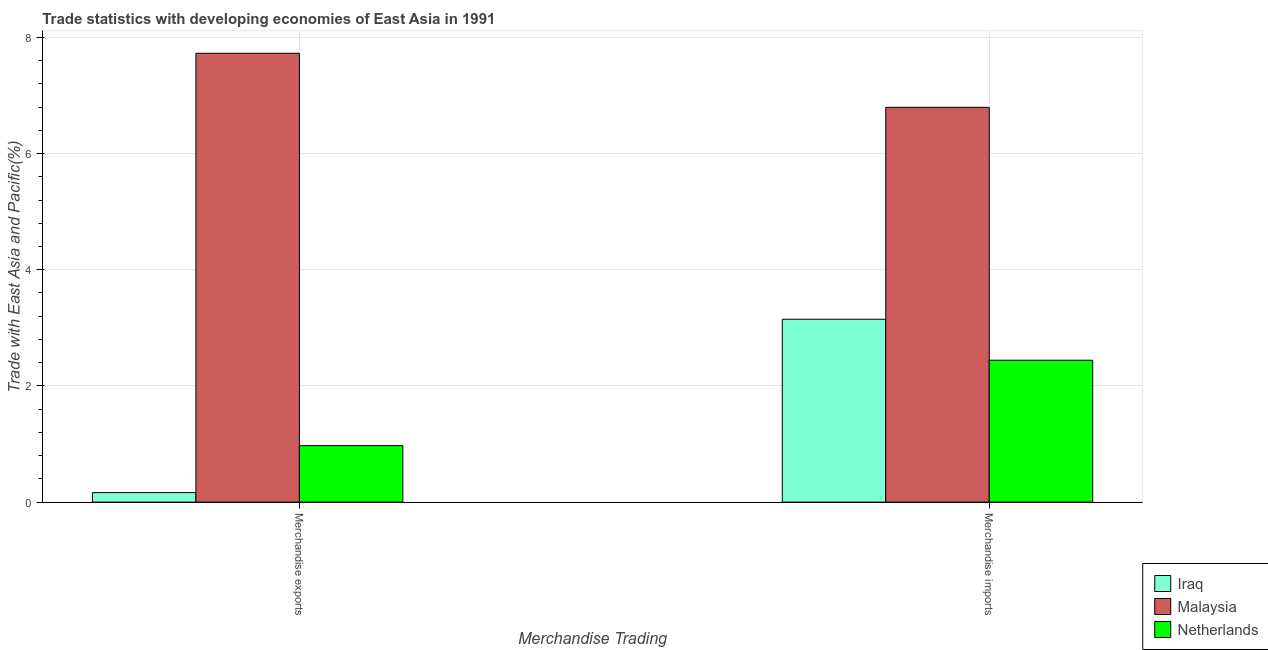How many different coloured bars are there?
Keep it short and to the point. 3. Are the number of bars per tick equal to the number of legend labels?
Give a very brief answer. Yes. What is the label of the 2nd group of bars from the left?
Provide a succinct answer. Merchandise imports. What is the merchandise exports in Malaysia?
Your answer should be very brief. 7.73. Across all countries, what is the maximum merchandise imports?
Provide a succinct answer. 6.8. Across all countries, what is the minimum merchandise exports?
Offer a terse response. 0.16. In which country was the merchandise exports maximum?
Offer a terse response. Malaysia. In which country was the merchandise exports minimum?
Your response must be concise. Iraq. What is the total merchandise exports in the graph?
Offer a very short reply. 8.86. What is the difference between the merchandise exports in Malaysia and that in Netherlands?
Ensure brevity in your answer.  6.75. What is the difference between the merchandise imports in Iraq and the merchandise exports in Netherlands?
Make the answer very short. 2.18. What is the average merchandise imports per country?
Provide a succinct answer. 4.13. What is the difference between the merchandise imports and merchandise exports in Iraq?
Keep it short and to the point. 2.98. What is the ratio of the merchandise exports in Netherlands to that in Malaysia?
Offer a terse response. 0.13. What does the 3rd bar from the left in Merchandise imports represents?
Your answer should be very brief. Netherlands. Does the graph contain any zero values?
Make the answer very short. No. Does the graph contain grids?
Your response must be concise. Yes. Where does the legend appear in the graph?
Offer a terse response. Bottom right. How many legend labels are there?
Your answer should be very brief. 3. What is the title of the graph?
Make the answer very short. Trade statistics with developing economies of East Asia in 1991. Does "New Zealand" appear as one of the legend labels in the graph?
Provide a succinct answer. No. What is the label or title of the X-axis?
Keep it short and to the point. Merchandise Trading. What is the label or title of the Y-axis?
Your answer should be compact. Trade with East Asia and Pacific(%). What is the Trade with East Asia and Pacific(%) of Iraq in Merchandise exports?
Your answer should be compact. 0.16. What is the Trade with East Asia and Pacific(%) of Malaysia in Merchandise exports?
Make the answer very short. 7.73. What is the Trade with East Asia and Pacific(%) of Netherlands in Merchandise exports?
Provide a short and direct response. 0.97. What is the Trade with East Asia and Pacific(%) of Iraq in Merchandise imports?
Keep it short and to the point. 3.15. What is the Trade with East Asia and Pacific(%) in Malaysia in Merchandise imports?
Your answer should be very brief. 6.8. What is the Trade with East Asia and Pacific(%) of Netherlands in Merchandise imports?
Make the answer very short. 2.44. Across all Merchandise Trading, what is the maximum Trade with East Asia and Pacific(%) of Iraq?
Give a very brief answer. 3.15. Across all Merchandise Trading, what is the maximum Trade with East Asia and Pacific(%) in Malaysia?
Your response must be concise. 7.73. Across all Merchandise Trading, what is the maximum Trade with East Asia and Pacific(%) of Netherlands?
Keep it short and to the point. 2.44. Across all Merchandise Trading, what is the minimum Trade with East Asia and Pacific(%) of Iraq?
Keep it short and to the point. 0.16. Across all Merchandise Trading, what is the minimum Trade with East Asia and Pacific(%) of Malaysia?
Provide a short and direct response. 6.8. Across all Merchandise Trading, what is the minimum Trade with East Asia and Pacific(%) of Netherlands?
Your answer should be compact. 0.97. What is the total Trade with East Asia and Pacific(%) of Iraq in the graph?
Your answer should be very brief. 3.31. What is the total Trade with East Asia and Pacific(%) in Malaysia in the graph?
Provide a short and direct response. 14.52. What is the total Trade with East Asia and Pacific(%) of Netherlands in the graph?
Provide a short and direct response. 3.41. What is the difference between the Trade with East Asia and Pacific(%) in Iraq in Merchandise exports and that in Merchandise imports?
Make the answer very short. -2.98. What is the difference between the Trade with East Asia and Pacific(%) of Malaysia in Merchandise exports and that in Merchandise imports?
Your answer should be compact. 0.93. What is the difference between the Trade with East Asia and Pacific(%) in Netherlands in Merchandise exports and that in Merchandise imports?
Ensure brevity in your answer.  -1.47. What is the difference between the Trade with East Asia and Pacific(%) of Iraq in Merchandise exports and the Trade with East Asia and Pacific(%) of Malaysia in Merchandise imports?
Your answer should be compact. -6.63. What is the difference between the Trade with East Asia and Pacific(%) in Iraq in Merchandise exports and the Trade with East Asia and Pacific(%) in Netherlands in Merchandise imports?
Provide a short and direct response. -2.28. What is the difference between the Trade with East Asia and Pacific(%) of Malaysia in Merchandise exports and the Trade with East Asia and Pacific(%) of Netherlands in Merchandise imports?
Make the answer very short. 5.28. What is the average Trade with East Asia and Pacific(%) in Iraq per Merchandise Trading?
Offer a terse response. 1.66. What is the average Trade with East Asia and Pacific(%) in Malaysia per Merchandise Trading?
Make the answer very short. 7.26. What is the average Trade with East Asia and Pacific(%) of Netherlands per Merchandise Trading?
Your response must be concise. 1.71. What is the difference between the Trade with East Asia and Pacific(%) in Iraq and Trade with East Asia and Pacific(%) in Malaysia in Merchandise exports?
Your answer should be compact. -7.56. What is the difference between the Trade with East Asia and Pacific(%) of Iraq and Trade with East Asia and Pacific(%) of Netherlands in Merchandise exports?
Provide a short and direct response. -0.81. What is the difference between the Trade with East Asia and Pacific(%) in Malaysia and Trade with East Asia and Pacific(%) in Netherlands in Merchandise exports?
Offer a terse response. 6.75. What is the difference between the Trade with East Asia and Pacific(%) of Iraq and Trade with East Asia and Pacific(%) of Malaysia in Merchandise imports?
Provide a short and direct response. -3.65. What is the difference between the Trade with East Asia and Pacific(%) in Iraq and Trade with East Asia and Pacific(%) in Netherlands in Merchandise imports?
Give a very brief answer. 0.71. What is the difference between the Trade with East Asia and Pacific(%) of Malaysia and Trade with East Asia and Pacific(%) of Netherlands in Merchandise imports?
Offer a very short reply. 4.35. What is the ratio of the Trade with East Asia and Pacific(%) in Iraq in Merchandise exports to that in Merchandise imports?
Give a very brief answer. 0.05. What is the ratio of the Trade with East Asia and Pacific(%) in Malaysia in Merchandise exports to that in Merchandise imports?
Ensure brevity in your answer.  1.14. What is the ratio of the Trade with East Asia and Pacific(%) in Netherlands in Merchandise exports to that in Merchandise imports?
Keep it short and to the point. 0.4. What is the difference between the highest and the second highest Trade with East Asia and Pacific(%) in Iraq?
Ensure brevity in your answer.  2.98. What is the difference between the highest and the second highest Trade with East Asia and Pacific(%) of Malaysia?
Offer a terse response. 0.93. What is the difference between the highest and the second highest Trade with East Asia and Pacific(%) of Netherlands?
Offer a very short reply. 1.47. What is the difference between the highest and the lowest Trade with East Asia and Pacific(%) in Iraq?
Offer a very short reply. 2.98. What is the difference between the highest and the lowest Trade with East Asia and Pacific(%) in Malaysia?
Your answer should be very brief. 0.93. What is the difference between the highest and the lowest Trade with East Asia and Pacific(%) in Netherlands?
Offer a very short reply. 1.47. 